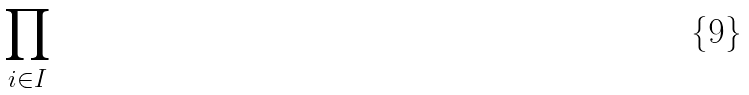<formula> <loc_0><loc_0><loc_500><loc_500>\prod _ { i \in I }</formula> 